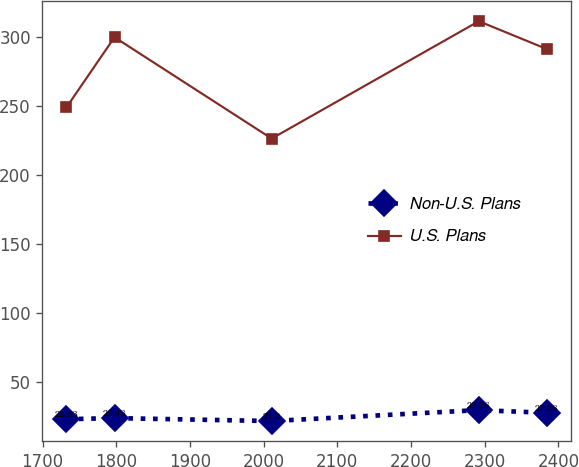Convert chart. <chart><loc_0><loc_0><loc_500><loc_500><line_chart><ecel><fcel>Non-U.S. Plans<fcel>U.S. Plans<nl><fcel>1732.47<fcel>22.63<fcel>249.16<nl><fcel>1797.62<fcel>23.43<fcel>300.05<nl><fcel>2010.88<fcel>21.3<fcel>226.45<nl><fcel>2291.97<fcel>29.26<fcel>311.69<nl><fcel>2383.93<fcel>27.28<fcel>291.53<nl></chart> 